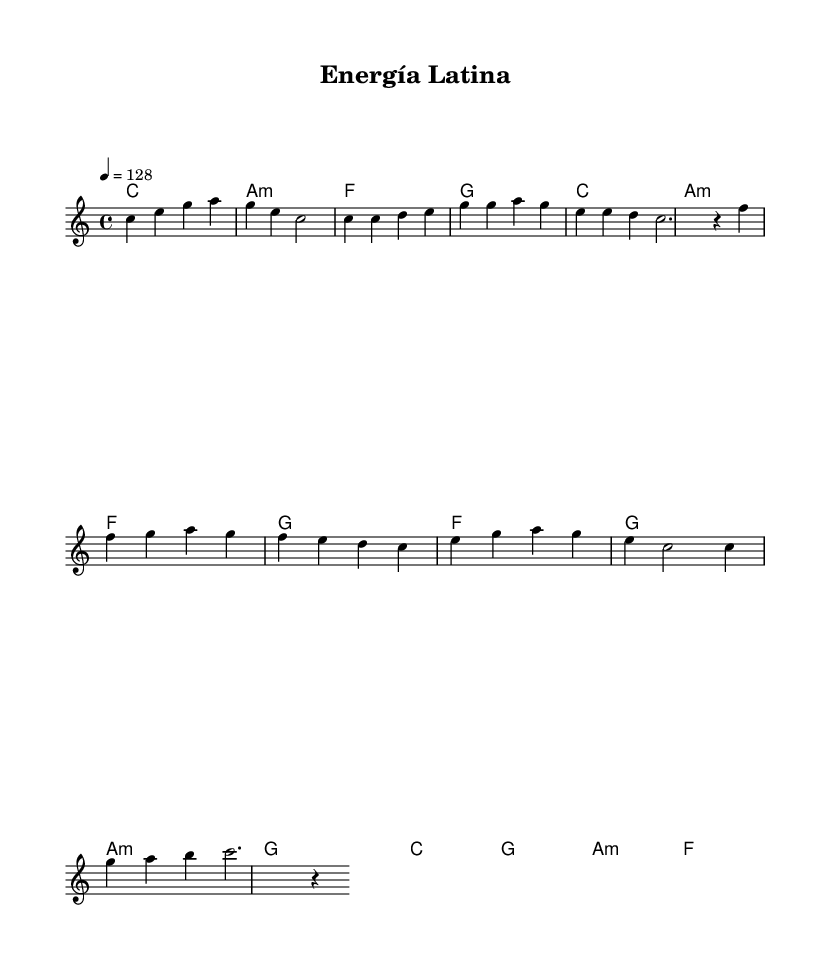What is the key signature of this music? The key signature is indicated in the global section with a key of C major, which has no sharps or flats.
Answer: C major What is the time signature of this music? The time signature appears in the global section and is shown as 4/4, which means there are four beats per measure.
Answer: 4/4 What is the tempo marking for this piece? The tempo is specified in the global section as 4 = 128, indicating a quarter note gets a tempo of 128 beats per minute.
Answer: 128 How many measures are in the chorus section? The chorus consists of two measures, which can be counted by identifying the music section labeled as the chorus and counting the measures there.
Answer: 2 Which chord is used in the pre-chorus section? The pre-chorus contains several chords, but the last chord in that section is G, which can be found after the notes in the pre-chorus measures.
Answer: G What is the melodic note that begins the verse? The first note of the verse can be identified by looking at the melody section under "Verse," and the first note there is C.
Answer: C What type of music is "Energía Latina" categorized as? The title "Energía Latina" suggests that it is an upbeat Latin pop piece, indicated by the style and tempo, which aligns with Latin pop characteristics.
Answer: Latin pop 